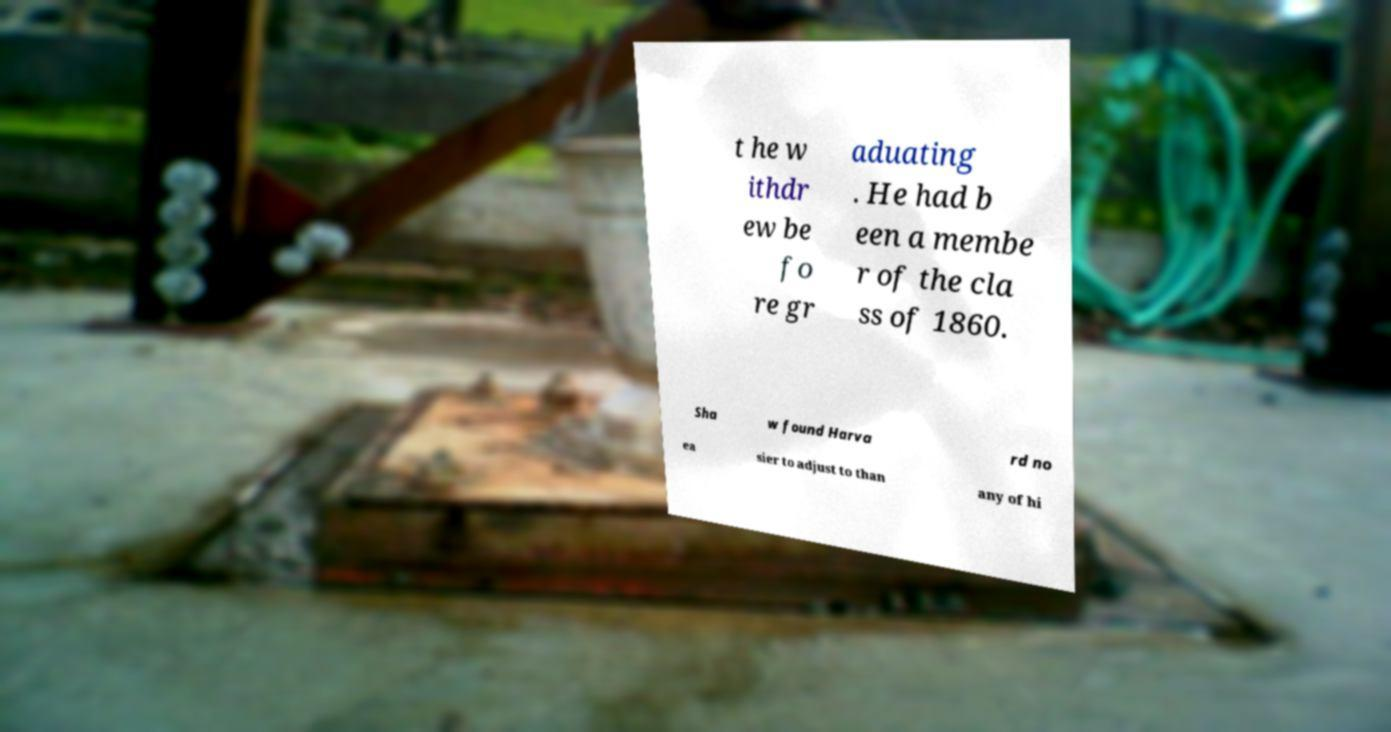Can you read and provide the text displayed in the image?This photo seems to have some interesting text. Can you extract and type it out for me? t he w ithdr ew be fo re gr aduating . He had b een a membe r of the cla ss of 1860. Sha w found Harva rd no ea sier to adjust to than any of hi 